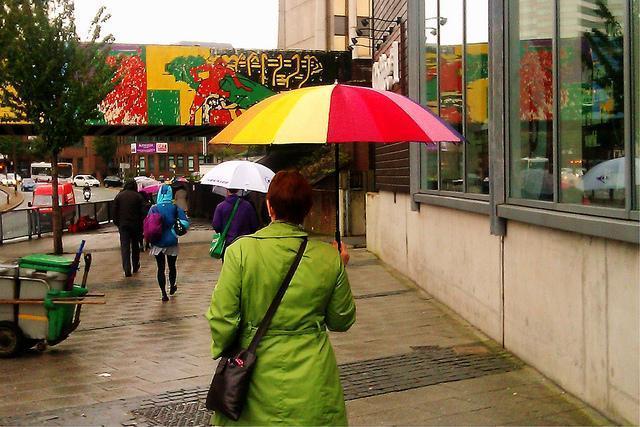How many colors are visible on the umbrella being held by the woman in the green coat?
Give a very brief answer. 7. How many people are in the picture?
Give a very brief answer. 3. 